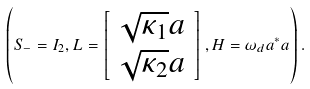<formula> <loc_0><loc_0><loc_500><loc_500>\left ( S _ { - } = I _ { 2 } , L = \left [ \begin{array} { c } \sqrt { \kappa _ { 1 } } a \\ \sqrt { \kappa _ { 2 } } a \end{array} \right ] , H = \omega _ { d } a ^ { \ast } a \right ) .</formula> 